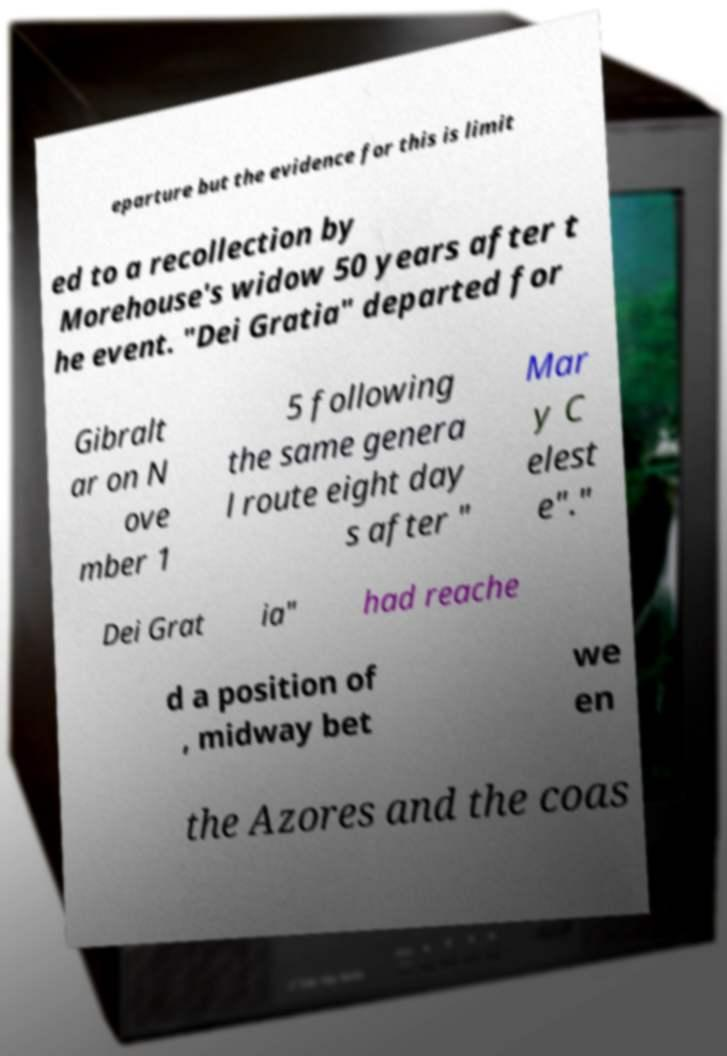Please identify and transcribe the text found in this image. eparture but the evidence for this is limit ed to a recollection by Morehouse's widow 50 years after t he event. "Dei Gratia" departed for Gibralt ar on N ove mber 1 5 following the same genera l route eight day s after " Mar y C elest e"." Dei Grat ia" had reache d a position of , midway bet we en the Azores and the coas 